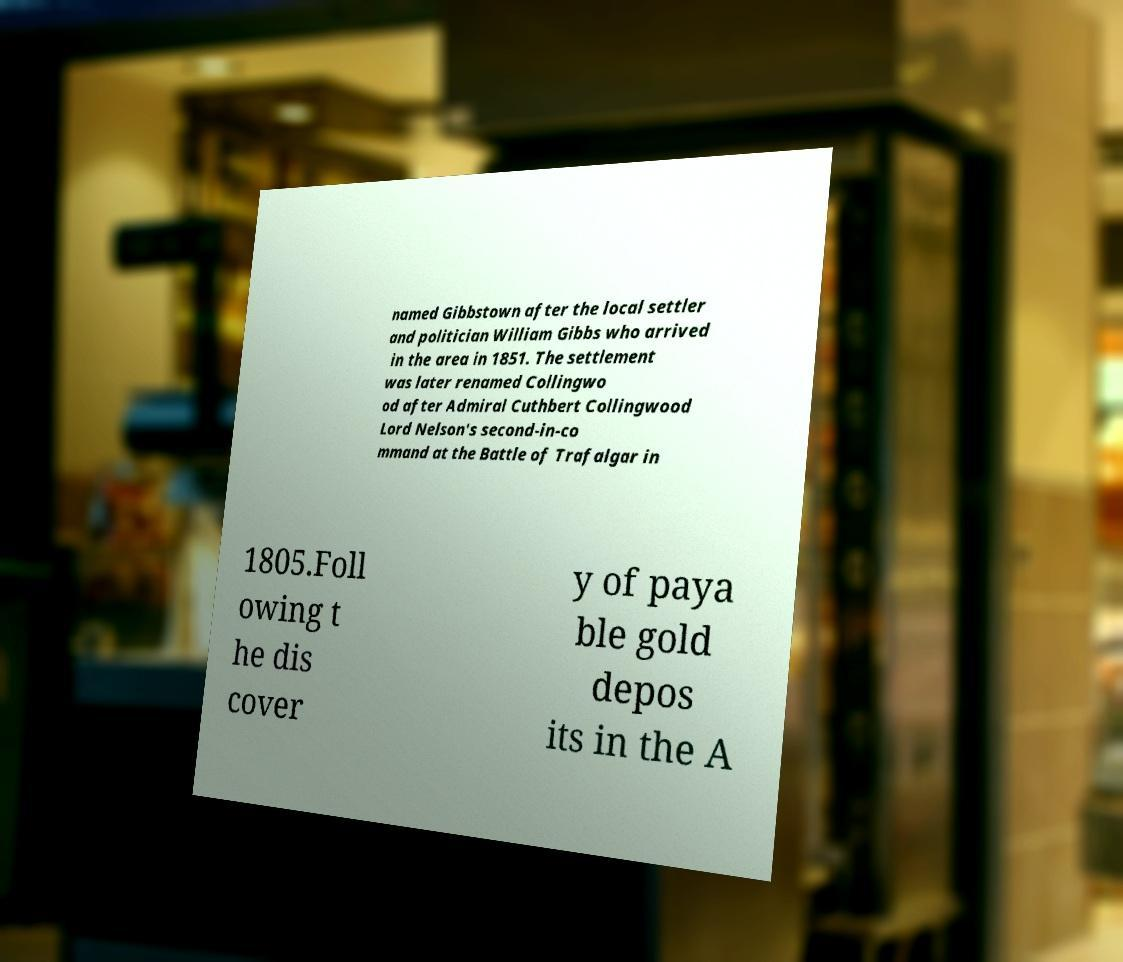Can you read and provide the text displayed in the image?This photo seems to have some interesting text. Can you extract and type it out for me? named Gibbstown after the local settler and politician William Gibbs who arrived in the area in 1851. The settlement was later renamed Collingwo od after Admiral Cuthbert Collingwood Lord Nelson's second-in-co mmand at the Battle of Trafalgar in 1805.Foll owing t he dis cover y of paya ble gold depos its in the A 